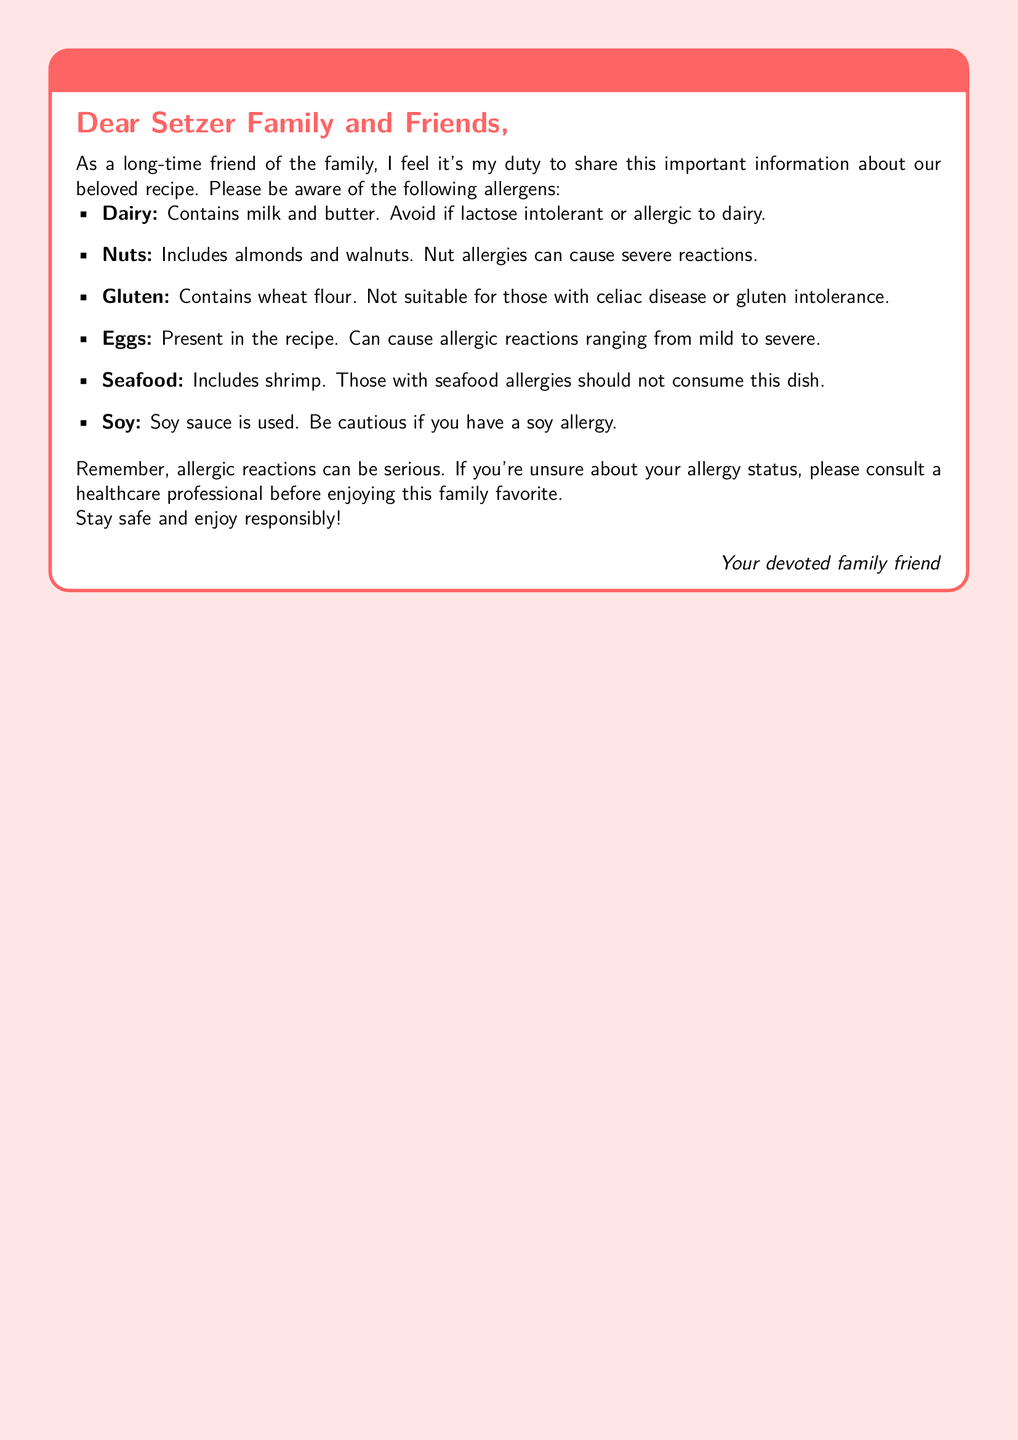What is the title of the document? The title appears prominently at the top of the document, which is "Allergy Alert: Ingredients Information for Setzer Family Recipe."
Answer: Allergy Alert: Ingredients Information for Setzer Family Recipe What type of allergies are mentioned? The document lists specific allergens that are contained in the recipe, including dairy, nuts, gluten, eggs, seafood, and soy.
Answer: Dairy, Nuts, Gluten, Eggs, Seafood, Soy How many allergens are listed in the document? The document provides a list of allergens, totaling six distinct types: dairy, nuts, gluten, eggs, seafood, and soy.
Answer: Six Which ingredient is present in the recipe as a dairy allergen? The document specifies that "milk and butter" are included as dairy ingredients in the recipe, posing a risk for those with dairy allergies.
Answer: Milk and butter What should individuals with seafood allergies do? The document advises those with seafood allergies not to consume the dish containing shrimp.
Answer: Not consume this dish What action is recommended for those unsure about their allergy status? The document recommends consulting a healthcare professional for anyone uncertain about their allergy before enjoying the recipe.
Answer: Consult a healthcare professional 